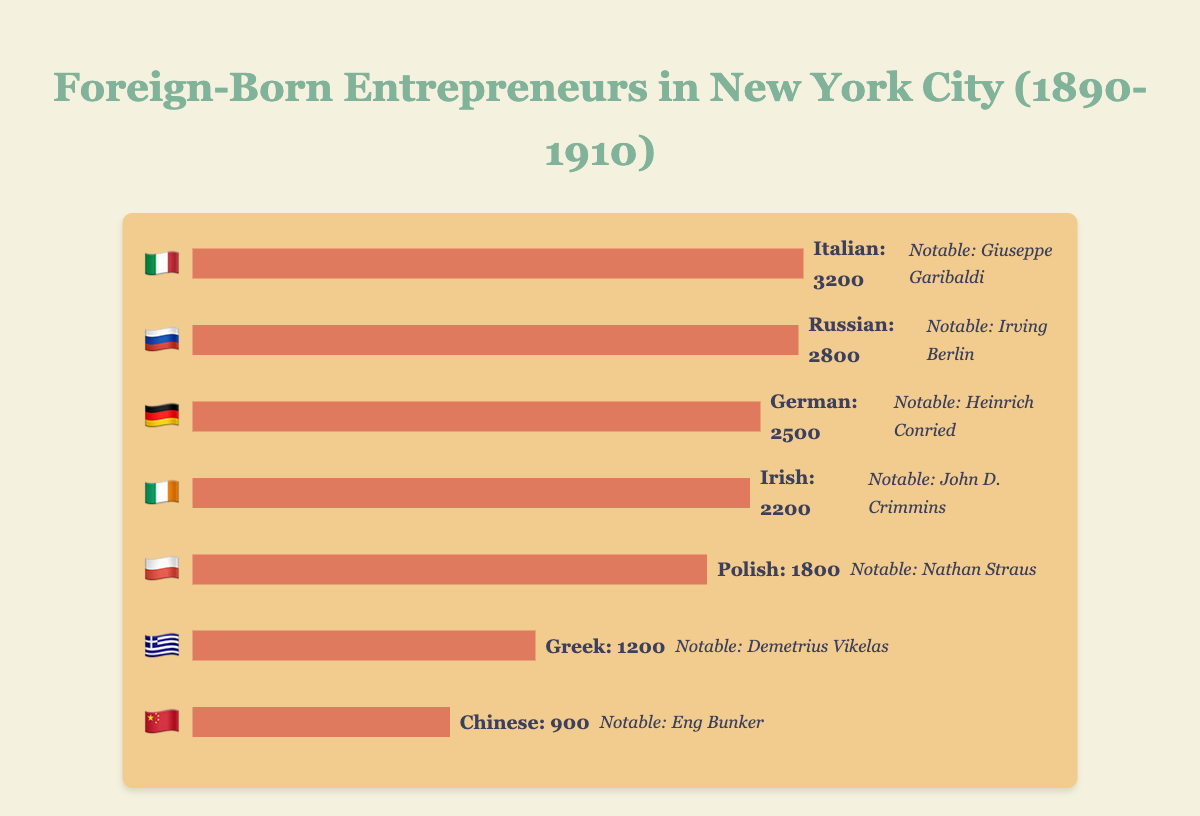Which nationality has the most entrepreneurs in New York City between 1890-1910? The figure shows bars representing different nationalities. The longest bar belongs to the Italian nationality, which indicates they have the most entrepreneurs.
Answer: Italian 🇮🇹 Which nationality has the least number of entrepreneurs? The figure shows bars of varying lengths for each nationality. The shortest bar represents the Chinese nationality, indicating they have the least number of entrepreneurs.
Answer: Chinese 🇨🇳 How many entrepreneurs come from Italian and Russian nationalities combined? The figure shows 3200 entrepreneurs from Italy and 2800 from Russia. Adding these two numbers gives 6000.
Answer: 6000 Which nationality has 2200 entrepreneurs? The figure includes bars and labels indicating the number of entrepreneurs per nationality. The Irish nationality has 2200 entrepreneurs as indicated by their bar and label.
Answer: Irish 🇮🇪 By how much do the Polish entrepreneurs outnumber the Greek entrepreneurs? The bar for Polish entrepreneurs indicates 1800 people, and the bar for Greek entrepreneurs shows 1200. The difference is 1800 - 1200 = 600.
Answer: 600 Who is the notable example for Russian entrepreneurs? The figure provides the names of notable examples next to each nationality's flag and bar. For Russian entrepreneurs, Irving Berlin is listed as the notable example.
Answer: Irving Berlin Which nationality has more entrepreneurs: Polish or Greek? The figure shows that Polish entrepreneurs have a longer bar representing 1800 people, whereas Greek entrepreneurs have a shorter bar representing 1200 people. Thus, Polish have more.
Answer: Polish 🇵🇱 List the nationalities and their notable examples. Referencing the figure, the nationalities and their notable examples are as follows: Italian - Giuseppe Garibaldi, Russian - Irving Berlin, German - Heinrich Conried, Irish - John D. Crimmins, Polish - Nathan Straus, Greek - Demetrius Vikelas, Chinese - Eng Bunker.
Answer: Italian: Giuseppe Garibaldi, Russian: Irving Berlin, German: Heinrich Conried, Irish: John D. Crimmins, Polish: Nathan Straus, Greek: Demetrius Vikelas, Chinese: Eng Bunker What percentage of the entrepreneurs are German? The figure shows 2500 German entrepreneurs out of the total (3200 + 2800 + 2500 + 2200 + 1800 + 1200 + 900 = 14600). The percentage is (2500 / 14600) * 100 = 17.12%.
Answer: 17.12% 